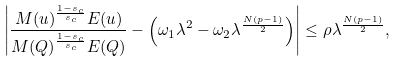<formula> <loc_0><loc_0><loc_500><loc_500>\left | \frac { M ( u ) ^ { \frac { 1 - s _ { c } } { s _ { c } } } E ( u ) } { M ( Q ) ^ { \frac { 1 - s _ { c } } { s _ { c } } } E ( Q ) } - \left ( \omega _ { 1 } \lambda ^ { 2 } - \omega _ { 2 } \lambda ^ { \frac { N ( p - 1 ) } { 2 } } \right ) \right | \leq \rho \lambda ^ { \frac { N ( p - 1 ) } { 2 } } ,</formula> 